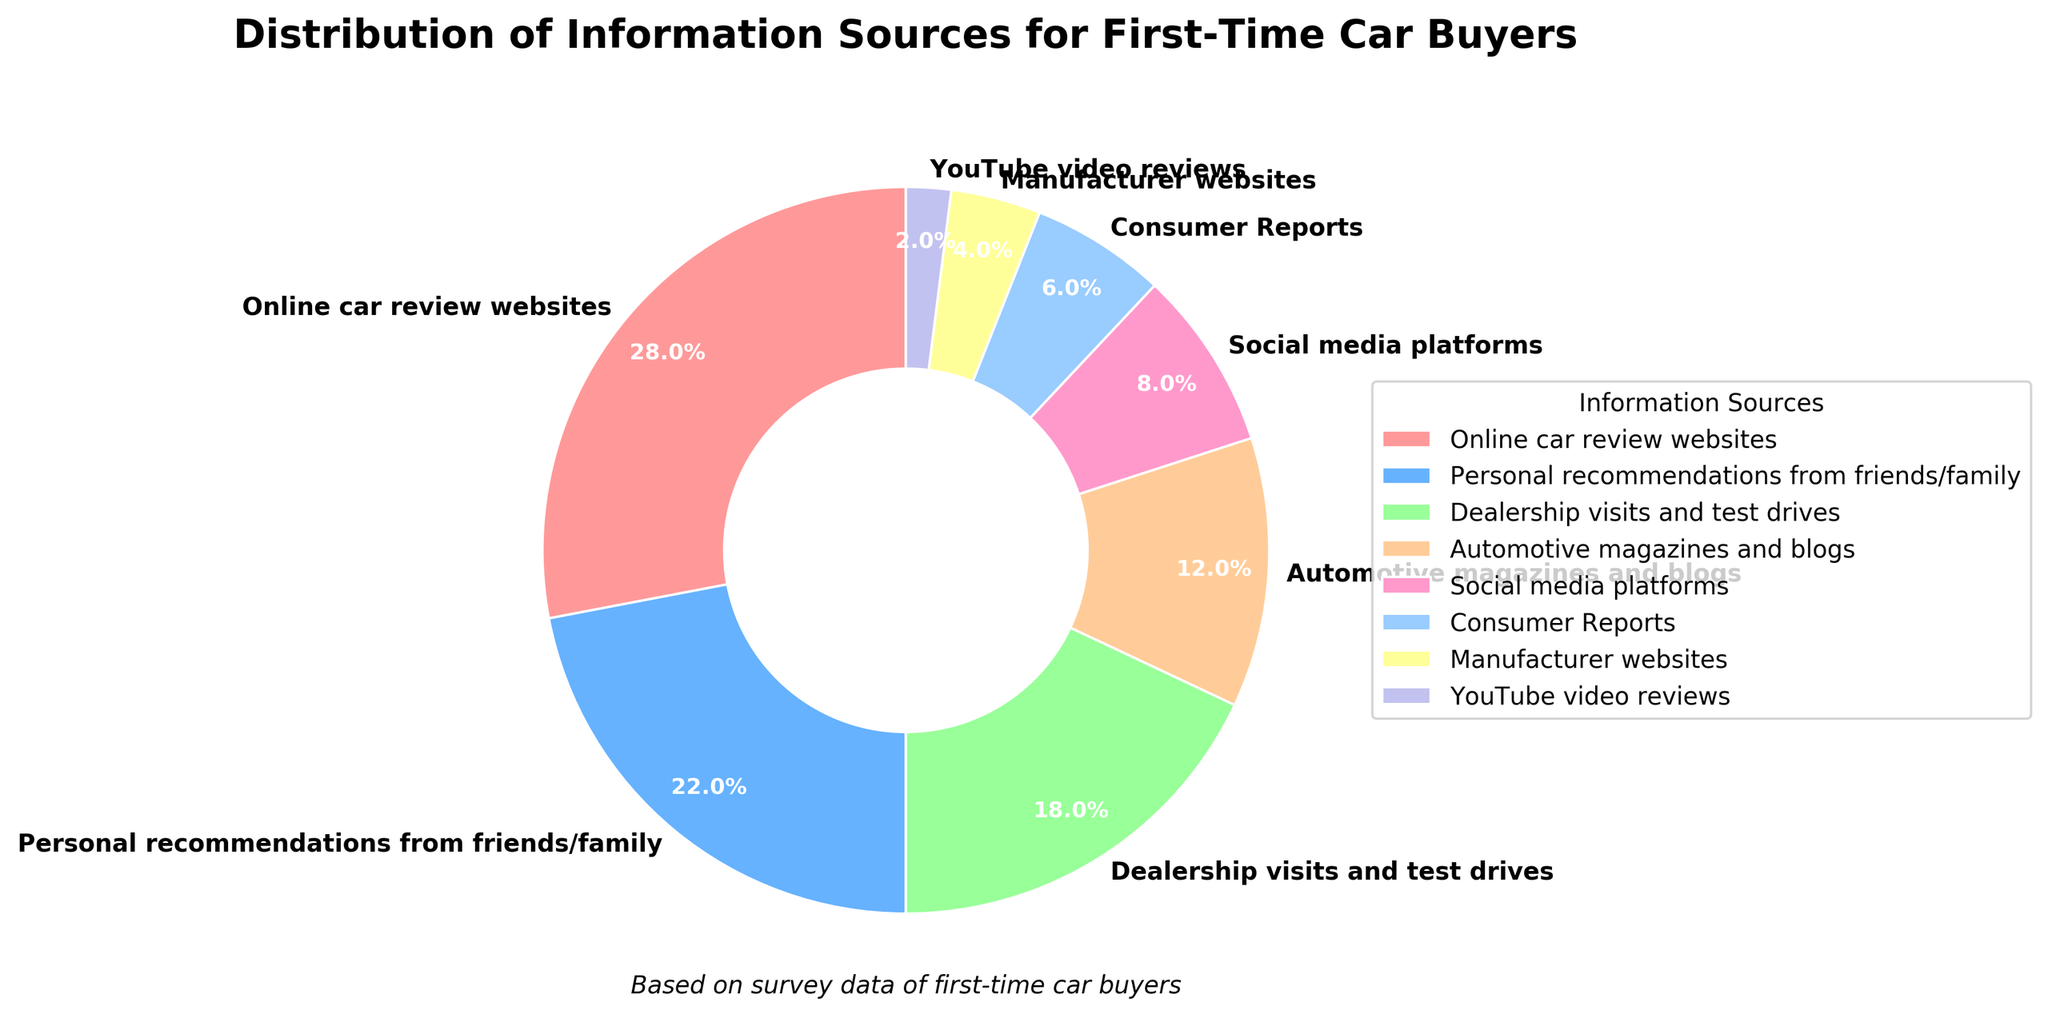What information source is used the most by first-time car buyers? To determine the predominant information source, examine the segment of the pie chart with the largest percentage. The "Online car review websites" segment has the highest data point at 28%.
Answer: Online car review websites Which information source is the least used by first-time car buyers? To identify the least utilized information source, locate the smallest segment in the pie chart. The "YouTube video reviews" segment has the smallest percentage at 2%.
Answer: YouTube video reviews What is the combined percentage of first-time car buyers using dealership visits, social media platforms, and manufacturer websites? First, identify the percentages of each of the three information sources from the pie chart: "Dealership visits and test drives" (18%), "Social media platforms" (8%), and "Manufacturer websites" (4%). Add these percentages together: 18% + 8% + 4%.
Answer: 30% Which is more popular among first-time car buyers: dealership visits or recommendations from friends/family? Compare the percentages of the two information sources. "Dealership visits and test drives" has 18% while "Personal recommendations from friends/family" has 22%. Since 22% is greater than 18%, recommendations from friends/family are more popular.
Answer: Recommendations from friends/family How much more popular are automotive magazines and blogs compared to Consumer Reports among first-time car buyers? Find the percentages for both information sources: "Automotive magazines and blogs" (12%) and "Consumer Reports" (6%). Subtract the percentage of "Consumer Reports" from "Automotive magazines and blogs": 12% - 6%.
Answer: 6% Are personal recommendations and dealership visits and test drives together more than half of the total information sources used by first-time car buyers? Add the percentages of "Personal recommendations from friends/family" (22%) and "Dealership visits and test drives" (18%). Check if their sum exceeds 50%: 22% + 18% = 40%, which is less than 50%.
Answer: No What percentage of first-time car buyers use sources other than online reviews, personal recommendations, and dealership visits? First, add up the percentages of "Online car review websites" (28%), "Personal recommendations from friends/family" (22%), and "Dealership visits and test drives" (18%): 28% + 22% + 18% = 68%. Subtract this from 100% to find the percentage using other sources: 100% - 68%.
Answer: 32% If the percentage of first-time car buyers using online car review websites doubled, what would the new percentage be? Take the original percentage of "Online car review websites," which is 28%, and double it: 28% * 2.
Answer: 56% Out of the listed information sources, how many have a percentage of 10% or higher before rounding? Identify the sources with a percentage of 10% or higher: "Online car review websites" (28%), "Personal recommendations from friends/family" (22%), "Dealership visits and test drives" (18%), and "Automotive magazines and blogs" (12%). Count these sources: there are 4 sources.
Answer: 4 